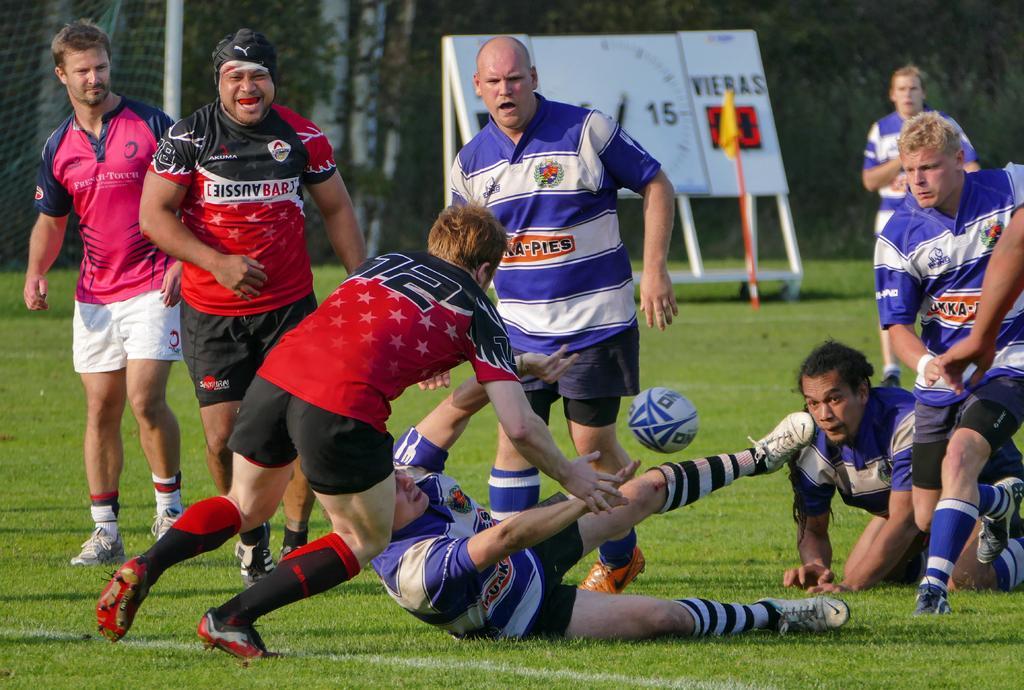In one or two sentences, can you explain what this image depicts? In this picture there are people playing football in the foreground area of the image on the grassland and two people lying on the grassland, there is a flag, board, net and trees in the background area. 